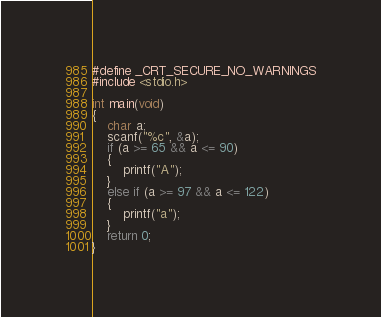<code> <loc_0><loc_0><loc_500><loc_500><_C++_>#define _CRT_SECURE_NO_WARNINGS
#include <stdio.h>

int main(void)
{
	char a;
	scanf("%c", &a);
	if (a >= 65 && a <= 90)
	{
		printf("A");
	}
	else if (a >= 97 && a <= 122)
	{
		printf("a");
	}
	return 0;
}</code> 